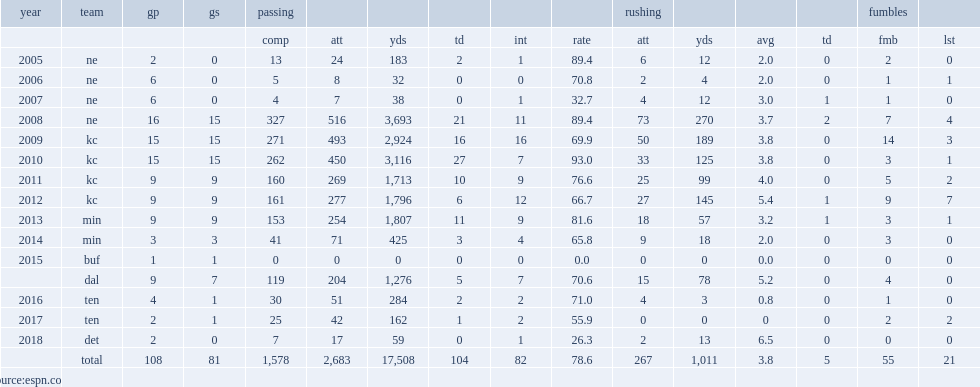Parse the table in full. {'header': ['year', 'team', 'gp', 'gs', 'passing', '', '', '', '', '', 'rushing', '', '', '', 'fumbles', ''], 'rows': [['', '', '', '', 'comp', 'att', 'yds', 'td', 'int', 'rate', 'att', 'yds', 'avg', 'td', 'fmb', 'lst'], ['2005', 'ne', '2', '0', '13', '24', '183', '2', '1', '89.4', '6', '12', '2.0', '0', '2', '0'], ['2006', 'ne', '6', '0', '5', '8', '32', '0', '0', '70.8', '2', '4', '2.0', '0', '1', '1'], ['2007', 'ne', '6', '0', '4', '7', '38', '0', '1', '32.7', '4', '12', '3.0', '1', '1', '0'], ['2008', 'ne', '16', '15', '327', '516', '3,693', '21', '11', '89.4', '73', '270', '3.7', '2', '7', '4'], ['2009', 'kc', '15', '15', '271', '493', '2,924', '16', '16', '69.9', '50', '189', '3.8', '0', '14', '3'], ['2010', 'kc', '15', '15', '262', '450', '3,116', '27', '7', '93.0', '33', '125', '3.8', '0', '3', '1'], ['2011', 'kc', '9', '9', '160', '269', '1,713', '10', '9', '76.6', '25', '99', '4.0', '0', '5', '2'], ['2012', 'kc', '9', '9', '161', '277', '1,796', '6', '12', '66.7', '27', '145', '5.4', '1', '9', '7'], ['2013', 'min', '9', '9', '153', '254', '1,807', '11', '9', '81.6', '18', '57', '3.2', '1', '3', '1'], ['2014', 'min', '3', '3', '41', '71', '425', '3', '4', '65.8', '9', '18', '2.0', '0', '3', '0'], ['2015', 'buf', '1', '1', '0', '0', '0', '0', '0', '0.0', '0', '0', '0.0', '0', '0', '0'], ['', 'dal', '9', '7', '119', '204', '1,276', '5', '7', '70.6', '15', '78', '5.2', '0', '4', '0'], ['2016', 'ten', '4', '1', '30', '51', '284', '2', '2', '71.0', '4', '3', '0.8', '0', '1', '0'], ['2017', 'ten', '2', '1', '25', '42', '162', '1', '2', '55.9', '0', '0', '0', '0', '2', '2'], ['2018', 'det', '2', '0', '7', '17', '59', '0', '1', '26.3', '2', '13', '6.5', '0', '0', '0'], ['', 'total', '108', '81', '1,578', '2,683', '17,508', '104', '82', '78.6', '267', '1,011', '3.8', '5', '55', '21'], ['source:espn.com', '', '', '', '', '', '', '', '', '', '', '', '', '', '', '']]} How many passing yards did matt cassel have in 2005? 183.0. 